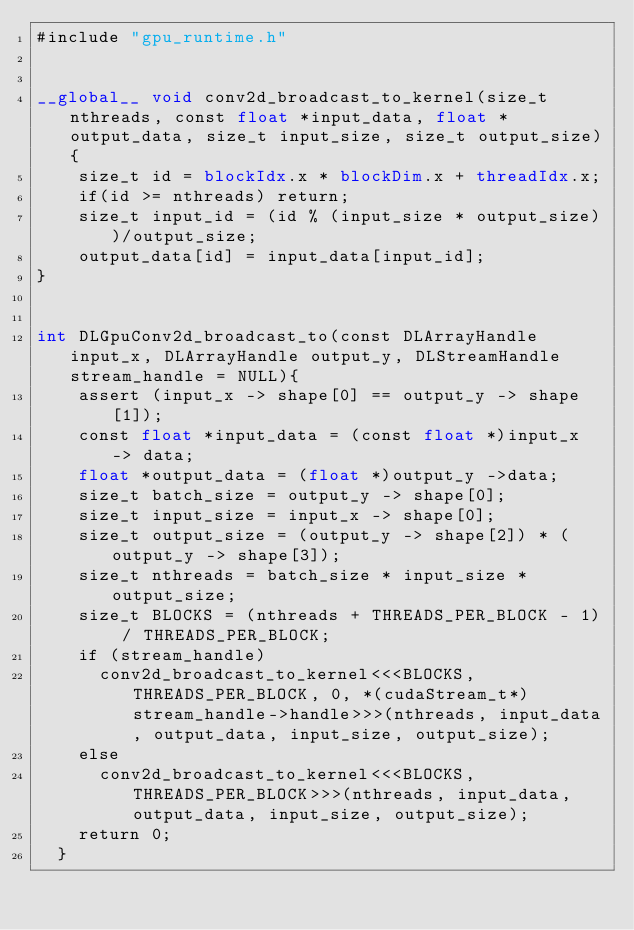Convert code to text. <code><loc_0><loc_0><loc_500><loc_500><_Cuda_>#include "gpu_runtime.h"


__global__ void conv2d_broadcast_to_kernel(size_t nthreads, const float *input_data, float * output_data, size_t input_size, size_t output_size){
    size_t id = blockIdx.x * blockDim.x + threadIdx.x;
    if(id >= nthreads) return;
    size_t input_id = (id % (input_size * output_size))/output_size;
    output_data[id] = input_data[input_id];
}


int DLGpuConv2d_broadcast_to(const DLArrayHandle input_x, DLArrayHandle output_y, DLStreamHandle stream_handle = NULL){
    assert (input_x -> shape[0] == output_y -> shape[1]);
    const float *input_data = (const float *)input_x -> data;
    float *output_data = (float *)output_y ->data;
    size_t batch_size = output_y -> shape[0];
    size_t input_size = input_x -> shape[0];
    size_t output_size = (output_y -> shape[2]) * (output_y -> shape[3]);
    size_t nthreads = batch_size * input_size * output_size;
    size_t BLOCKS = (nthreads + THREADS_PER_BLOCK - 1) / THREADS_PER_BLOCK;
    if (stream_handle)
      conv2d_broadcast_to_kernel<<<BLOCKS, THREADS_PER_BLOCK, 0, *(cudaStream_t*)stream_handle->handle>>>(nthreads, input_data, output_data, input_size, output_size);
    else
      conv2d_broadcast_to_kernel<<<BLOCKS, THREADS_PER_BLOCK>>>(nthreads, input_data, output_data, input_size, output_size);
    return 0;
  }</code> 